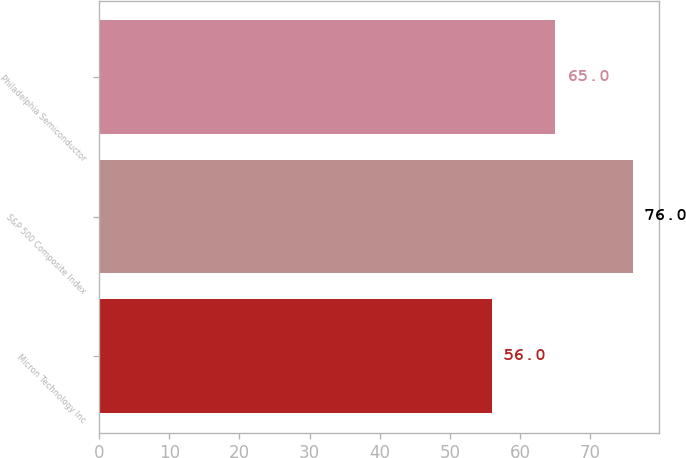Convert chart to OTSL. <chart><loc_0><loc_0><loc_500><loc_500><bar_chart><fcel>Micron Technology Inc<fcel>S&P 500 Composite Index<fcel>Philadelphia Semiconductor<nl><fcel>56<fcel>76<fcel>65<nl></chart> 